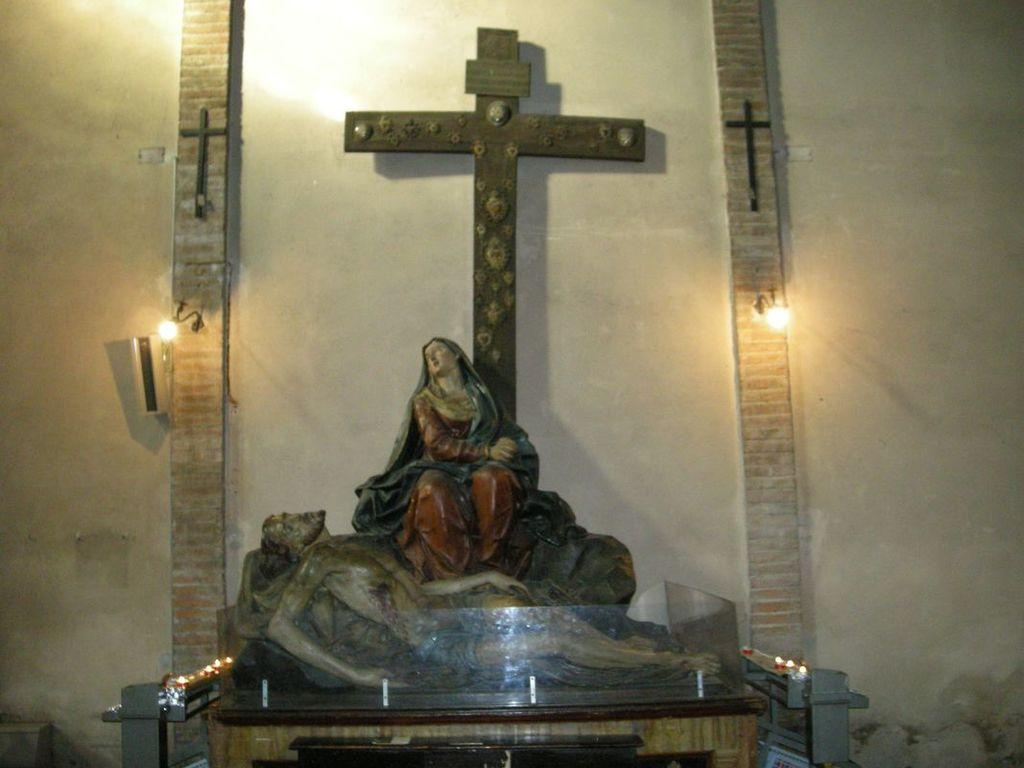What is the main subject of the image? There is a sculpture in the image. What can be seen in the background of the image? There is a wall in the background of the image. What else is visible in the image besides the sculpture and wall? There are lights visible in the image. What symbol can be seen in the image? There is a cross in the image. What is the price of the branch in the image? There is no branch present in the image, so it is not possible to determine its price. 